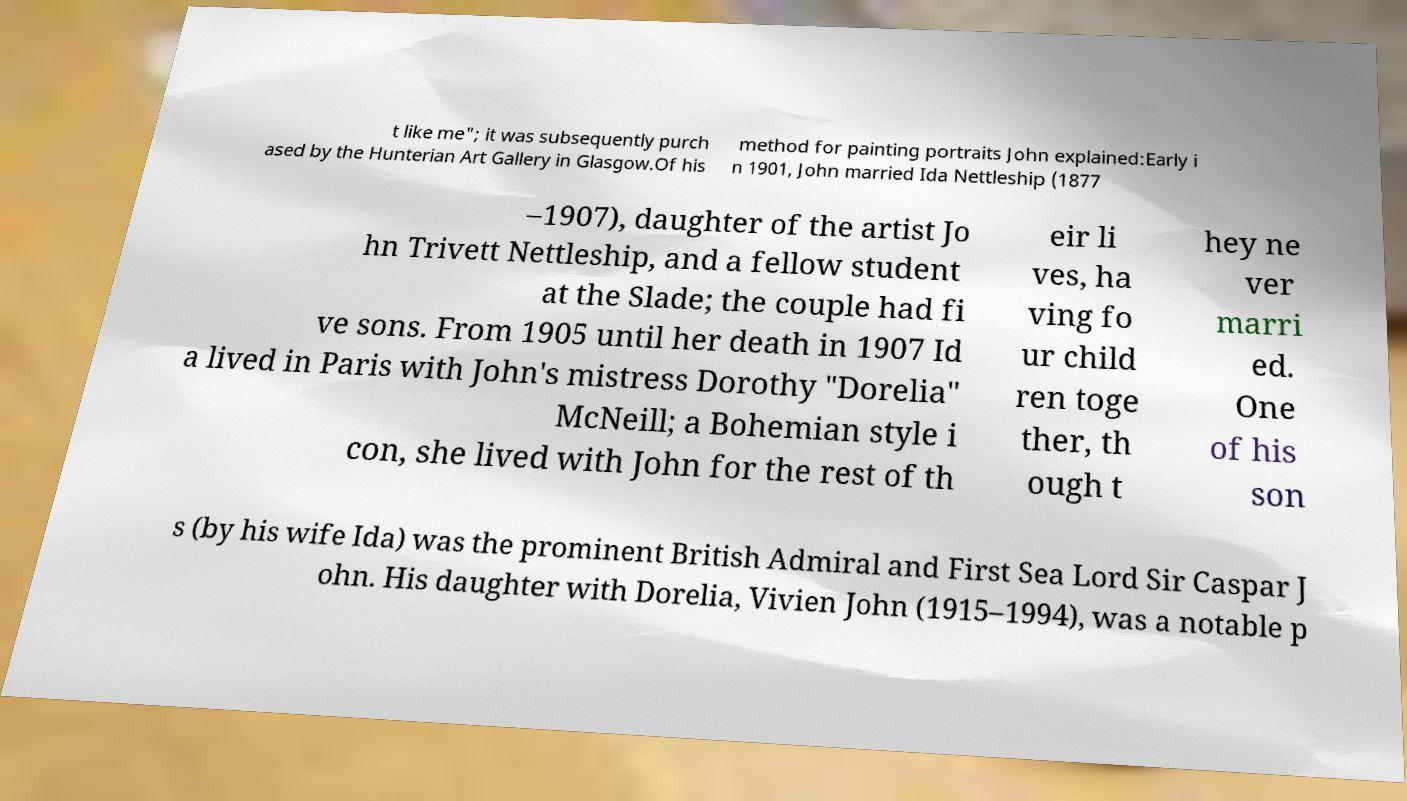There's text embedded in this image that I need extracted. Can you transcribe it verbatim? t like me"; it was subsequently purch ased by the Hunterian Art Gallery in Glasgow.Of his method for painting portraits John explained:Early i n 1901, John married Ida Nettleship (1877 –1907), daughter of the artist Jo hn Trivett Nettleship, and a fellow student at the Slade; the couple had fi ve sons. From 1905 until her death in 1907 Id a lived in Paris with John's mistress Dorothy "Dorelia" McNeill; a Bohemian style i con, she lived with John for the rest of th eir li ves, ha ving fo ur child ren toge ther, th ough t hey ne ver marri ed. One of his son s (by his wife Ida) was the prominent British Admiral and First Sea Lord Sir Caspar J ohn. His daughter with Dorelia, Vivien John (1915–1994), was a notable p 